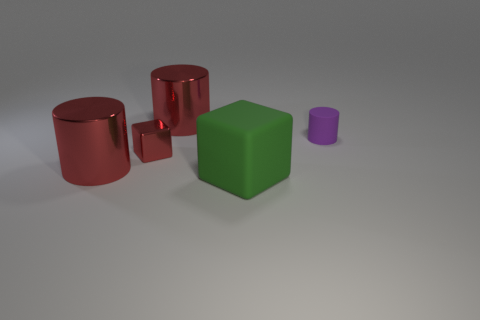Subtract all small purple rubber cylinders. How many cylinders are left? 2 Subtract all green blocks. How many blocks are left? 1 Add 3 large gray rubber things. How many objects exist? 8 Subtract 0 green spheres. How many objects are left? 5 Subtract all cylinders. How many objects are left? 2 Subtract all green cylinders. Subtract all purple balls. How many cylinders are left? 3 Subtract all red cylinders. How many cyan blocks are left? 0 Subtract all small cyan metal spheres. Subtract all big objects. How many objects are left? 2 Add 2 purple objects. How many purple objects are left? 3 Add 3 cylinders. How many cylinders exist? 6 